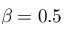Convert formula to latex. <formula><loc_0><loc_0><loc_500><loc_500>\beta = 0 . 5</formula> 